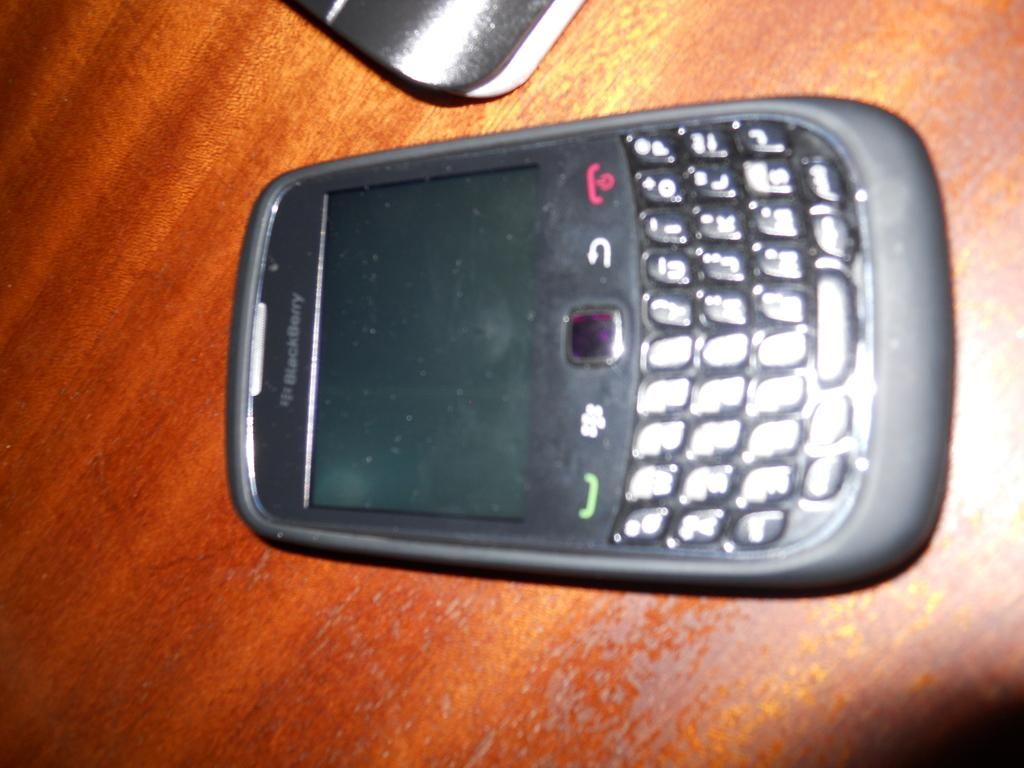<image>
Create a compact narrative representing the image presented. Blackberry mobile phone laying on a brown table 